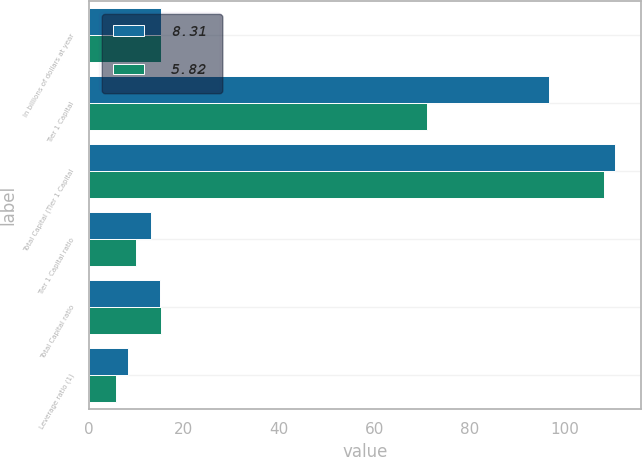Convert chart. <chart><loc_0><loc_0><loc_500><loc_500><stacked_bar_chart><ecel><fcel>In billions of dollars at year<fcel>Tier 1 Capital<fcel>Total Capital (Tier 1 Capital<fcel>Tier 1 Capital ratio<fcel>Total Capital ratio<fcel>Leverage ratio (1)<nl><fcel>8.31<fcel>15.105<fcel>96.8<fcel>110.6<fcel>13.16<fcel>15.03<fcel>8.31<nl><fcel>5.82<fcel>15.105<fcel>71<fcel>108.4<fcel>9.94<fcel>15.18<fcel>5.82<nl></chart> 